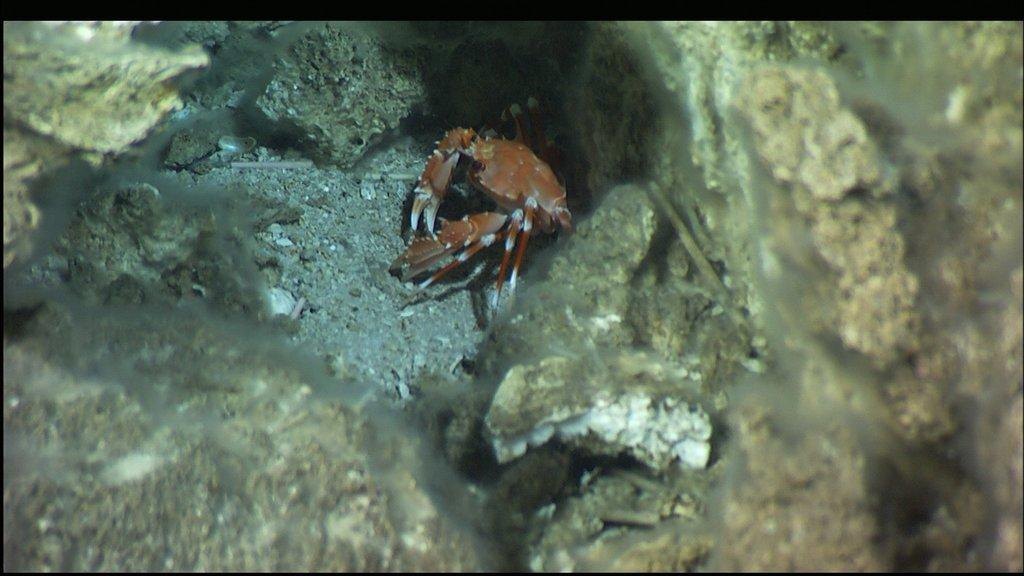What type of creature is present in the image? There is an insect in the image. Can you describe the color pattern of the insect? The insect has brown and white colors. What other object can be seen in the image? There is a rock in the image. What type of boat is visible in the image? There is no boat present in the image. How is the hose connected to the office in the image? There is no office or hose present in the image. 